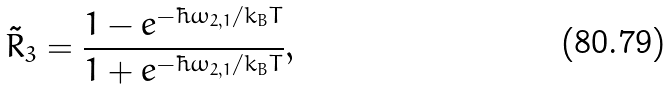<formula> <loc_0><loc_0><loc_500><loc_500>\tilde { R } _ { 3 } = \frac { 1 - e ^ { - \hbar { \omega } _ { 2 , 1 } / k _ { B } T } } { 1 + e ^ { - \hbar { \omega } _ { 2 , 1 } / k _ { B } T } } ,</formula> 